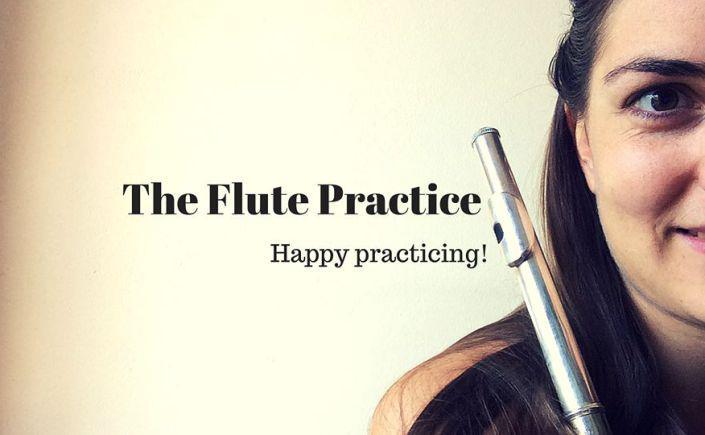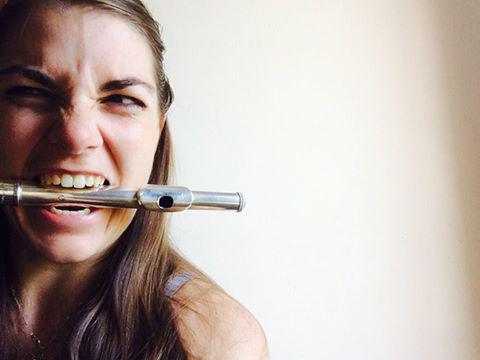The first image is the image on the left, the second image is the image on the right. For the images displayed, is the sentence "One image shows a woman with a flute touching her mouth." factually correct? Answer yes or no. Yes. The first image is the image on the left, the second image is the image on the right. For the images displayed, is the sentence "One image shows a woman with a flute alongside her face on the left, and the other image shows a model with a flute horizontal to her mouth." factually correct? Answer yes or no. Yes. 